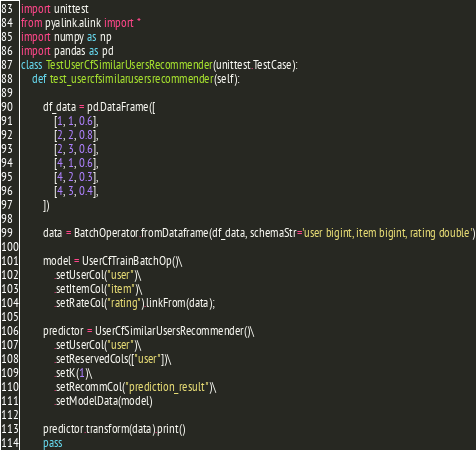<code> <loc_0><loc_0><loc_500><loc_500><_Python_>import unittest
from pyalink.alink import *
import numpy as np
import pandas as pd
class TestUserCfSimilarUsersRecommender(unittest.TestCase):
    def test_usercfsimilarusersrecommender(self):

        df_data = pd.DataFrame([
            [1, 1, 0.6],
            [2, 2, 0.8],
            [2, 3, 0.6],
            [4, 1, 0.6],
            [4, 2, 0.3],
            [4, 3, 0.4],
        ])
        
        data = BatchOperator.fromDataframe(df_data, schemaStr='user bigint, item bigint, rating double')
        
        model = UserCfTrainBatchOp()\
            .setUserCol("user")\
            .setItemCol("item")\
            .setRateCol("rating").linkFrom(data);
        
        predictor = UserCfSimilarUsersRecommender()\
            .setUserCol("user")\
            .setReservedCols(["user"])\
            .setK(1)\
            .setRecommCol("prediction_result")\
            .setModelData(model)
        
        predictor.transform(data).print()
        pass</code> 